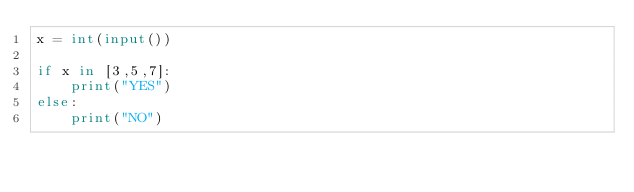<code> <loc_0><loc_0><loc_500><loc_500><_Python_>x = int(input())

if x in [3,5,7]:
    print("YES")
else:
    print("NO")</code> 